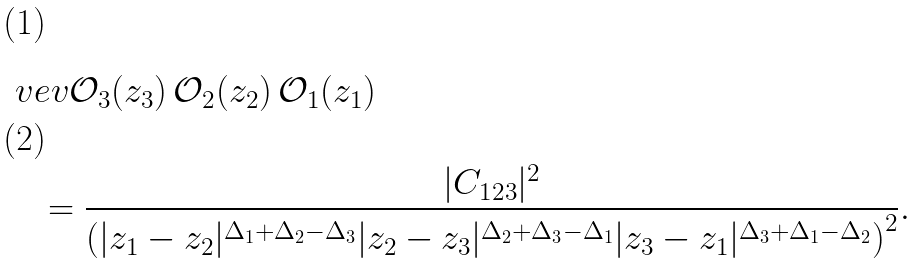Convert formula to latex. <formula><loc_0><loc_0><loc_500><loc_500>& \ v e v { \mathcal { O } _ { 3 } ( z _ { 3 } ) \, \mathcal { O } _ { 2 } ( z _ { 2 } ) \, \mathcal { O } _ { 1 } ( z _ { 1 } ) } \\ & \quad = \frac { | C _ { 1 2 3 } | ^ { 2 } } { \left ( | z _ { 1 } - z _ { 2 } | ^ { \Delta _ { 1 } + \Delta _ { 2 } - \Delta _ { 3 } } | z _ { 2 } - z _ { 3 } | ^ { \Delta _ { 2 } + \Delta _ { 3 } - \Delta _ { 1 } } | z _ { 3 } - z _ { 1 } | ^ { \Delta _ { 3 } + \Delta _ { 1 } - \Delta _ { 2 } } \right ) ^ { 2 } } .</formula> 